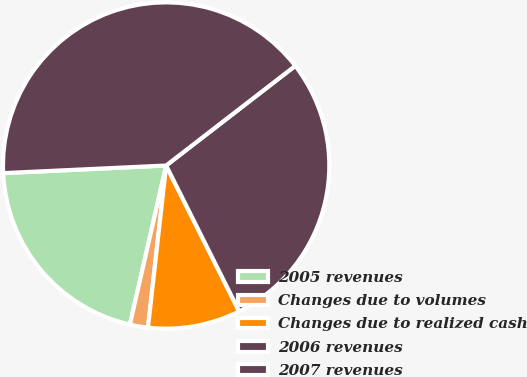Convert chart to OTSL. <chart><loc_0><loc_0><loc_500><loc_500><pie_chart><fcel>2005 revenues<fcel>Changes due to volumes<fcel>Changes due to realized cash<fcel>2006 revenues<fcel>2007 revenues<nl><fcel>20.69%<fcel>1.79%<fcel>9.17%<fcel>28.07%<fcel>40.28%<nl></chart> 